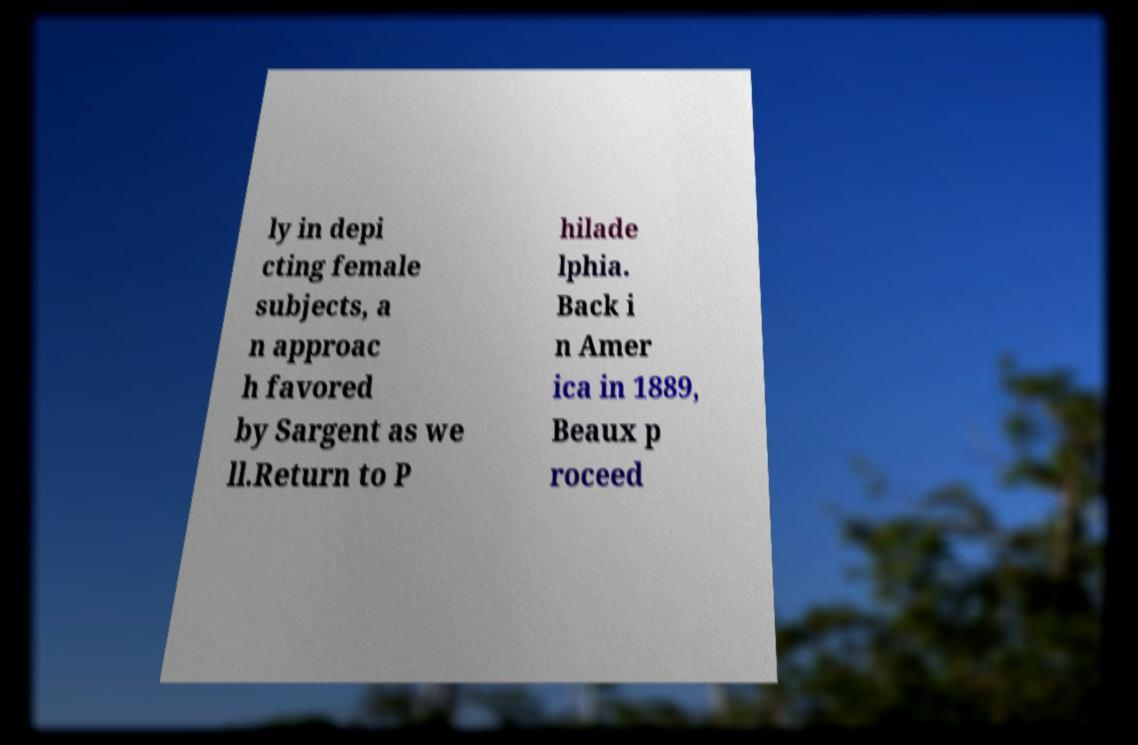What messages or text are displayed in this image? I need them in a readable, typed format. ly in depi cting female subjects, a n approac h favored by Sargent as we ll.Return to P hilade lphia. Back i n Amer ica in 1889, Beaux p roceed 